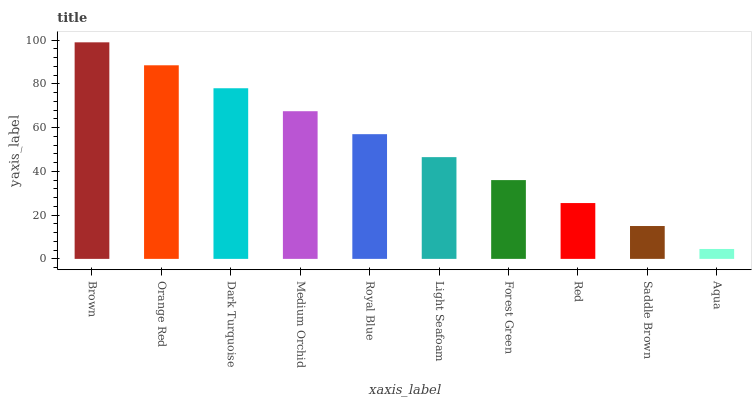Is Aqua the minimum?
Answer yes or no. Yes. Is Brown the maximum?
Answer yes or no. Yes. Is Orange Red the minimum?
Answer yes or no. No. Is Orange Red the maximum?
Answer yes or no. No. Is Brown greater than Orange Red?
Answer yes or no. Yes. Is Orange Red less than Brown?
Answer yes or no. Yes. Is Orange Red greater than Brown?
Answer yes or no. No. Is Brown less than Orange Red?
Answer yes or no. No. Is Royal Blue the high median?
Answer yes or no. Yes. Is Light Seafoam the low median?
Answer yes or no. Yes. Is Forest Green the high median?
Answer yes or no. No. Is Brown the low median?
Answer yes or no. No. 